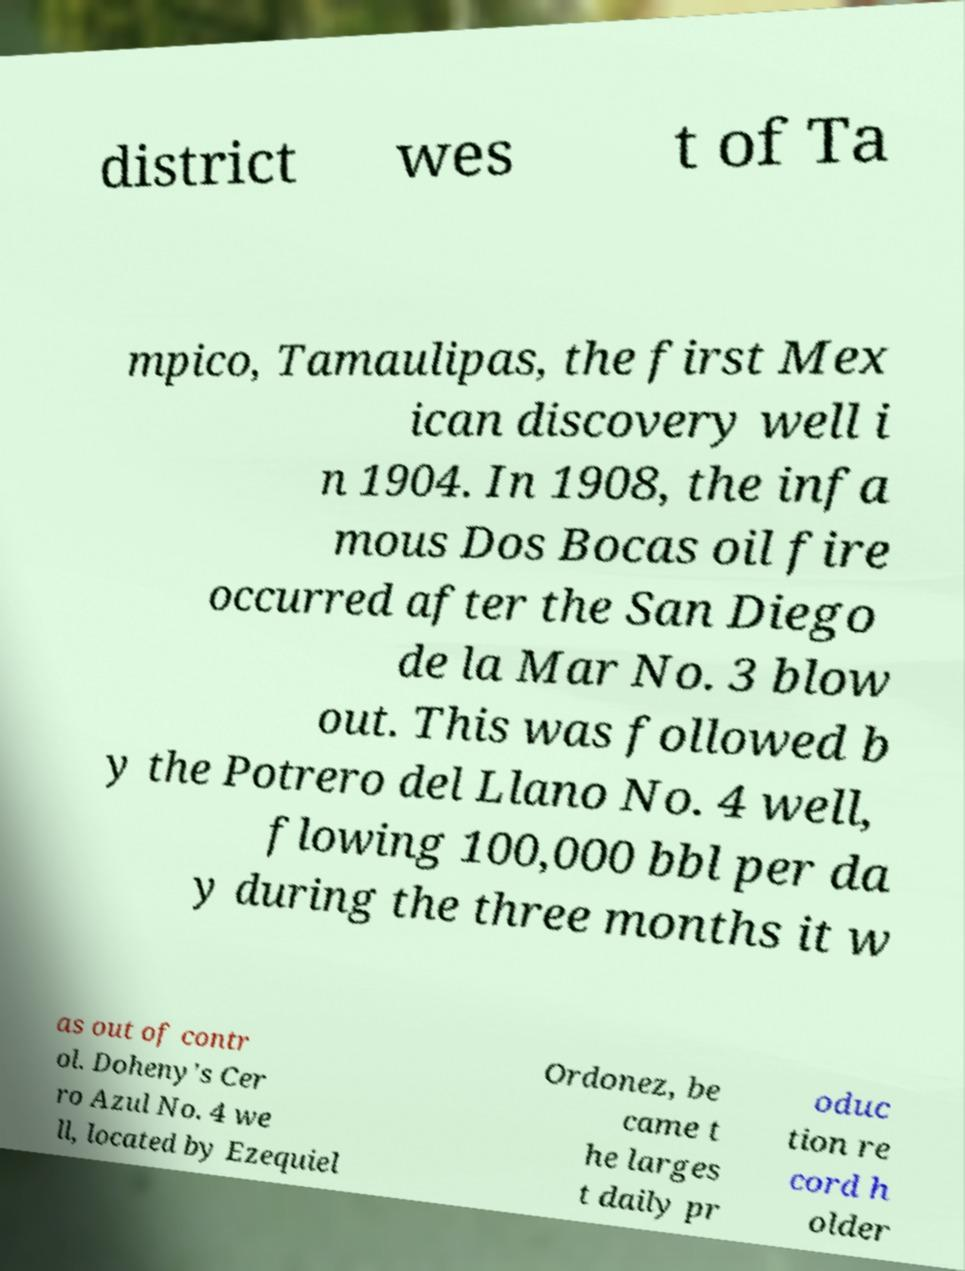For documentation purposes, I need the text within this image transcribed. Could you provide that? district wes t of Ta mpico, Tamaulipas, the first Mex ican discovery well i n 1904. In 1908, the infa mous Dos Bocas oil fire occurred after the San Diego de la Mar No. 3 blow out. This was followed b y the Potrero del Llano No. 4 well, flowing 100,000 bbl per da y during the three months it w as out of contr ol. Doheny's Cer ro Azul No. 4 we ll, located by Ezequiel Ordonez, be came t he larges t daily pr oduc tion re cord h older 